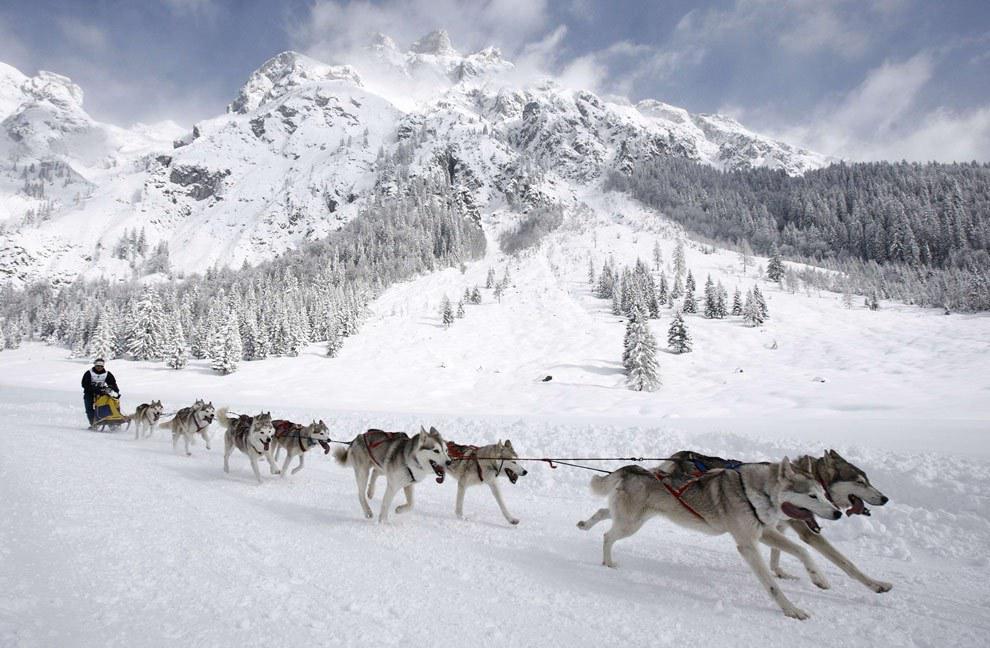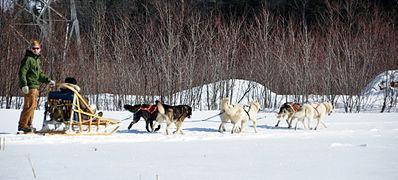The first image is the image on the left, the second image is the image on the right. Assess this claim about the two images: "At least one of the images features six or less dogs pulling a sled.". Correct or not? Answer yes or no. Yes. The first image is the image on the left, the second image is the image on the right. Given the left and right images, does the statement "Right image shows a sled dog team with a mountain range behind them." hold true? Answer yes or no. No. 